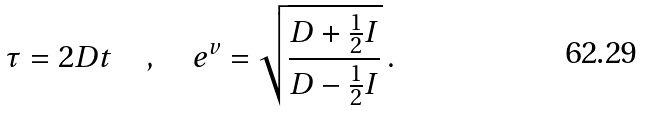<formula> <loc_0><loc_0><loc_500><loc_500>\tau = 2 D t \quad , \quad e ^ { v } = \sqrt { \frac { D + \frac { 1 } { 2 } I } { D - \frac { 1 } { 2 } I } } \, .</formula> 